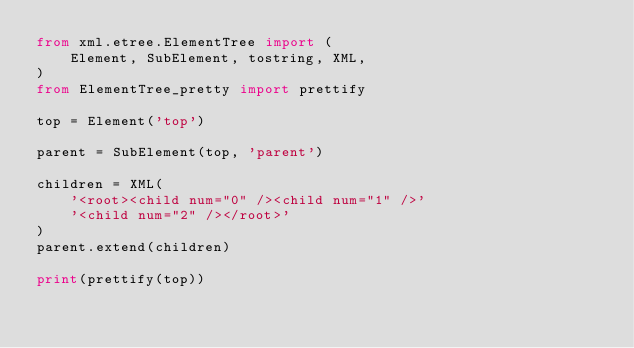<code> <loc_0><loc_0><loc_500><loc_500><_Python_>from xml.etree.ElementTree import (
    Element, SubElement, tostring, XML,
)
from ElementTree_pretty import prettify

top = Element('top')

parent = SubElement(top, 'parent')

children = XML(
    '<root><child num="0" /><child num="1" />'
    '<child num="2" /></root>'
)
parent.extend(children)

print(prettify(top))
</code> 